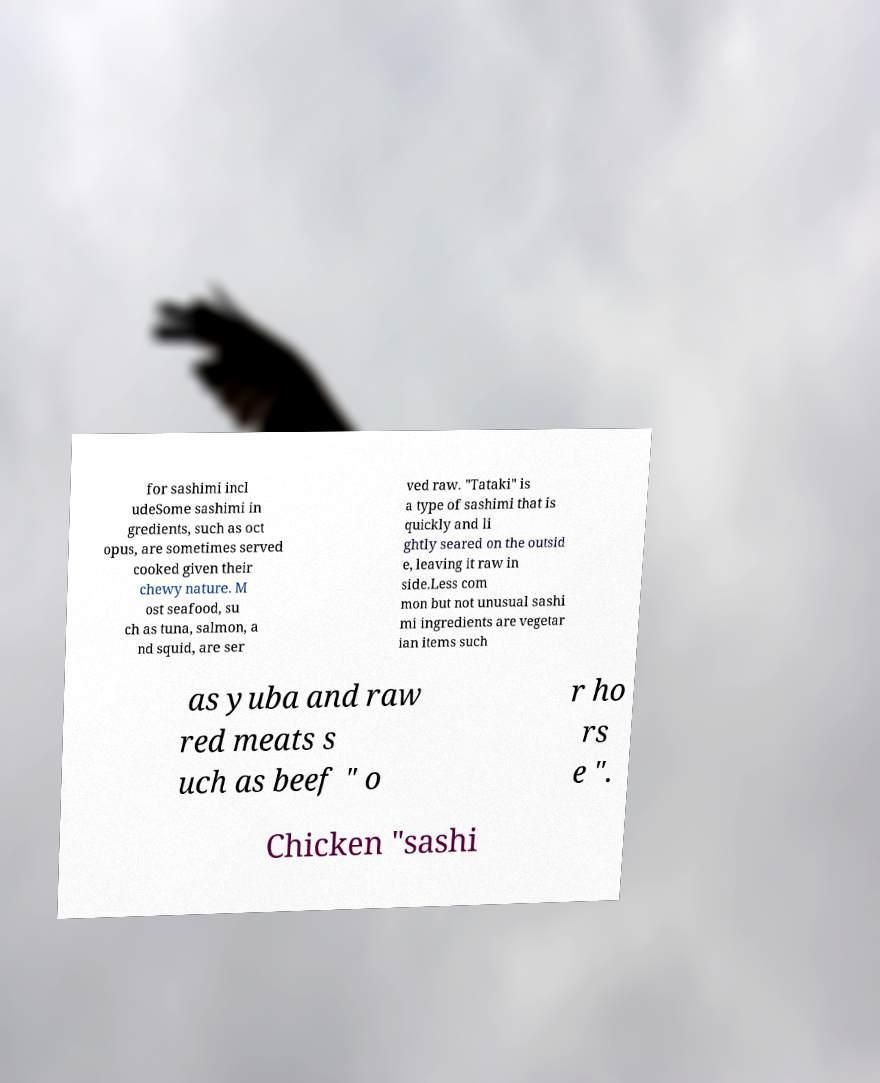Please identify and transcribe the text found in this image. for sashimi incl udeSome sashimi in gredients, such as oct opus, are sometimes served cooked given their chewy nature. M ost seafood, su ch as tuna, salmon, a nd squid, are ser ved raw. "Tataki" is a type of sashimi that is quickly and li ghtly seared on the outsid e, leaving it raw in side.Less com mon but not unusual sashi mi ingredients are vegetar ian items such as yuba and raw red meats s uch as beef " o r ho rs e ". Chicken "sashi 